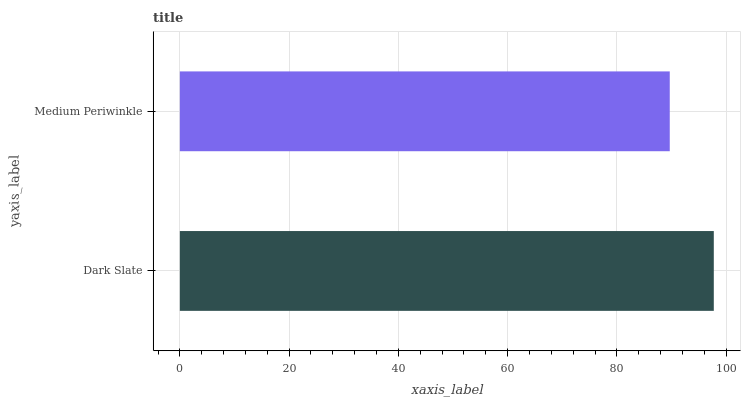Is Medium Periwinkle the minimum?
Answer yes or no. Yes. Is Dark Slate the maximum?
Answer yes or no. Yes. Is Medium Periwinkle the maximum?
Answer yes or no. No. Is Dark Slate greater than Medium Periwinkle?
Answer yes or no. Yes. Is Medium Periwinkle less than Dark Slate?
Answer yes or no. Yes. Is Medium Periwinkle greater than Dark Slate?
Answer yes or no. No. Is Dark Slate less than Medium Periwinkle?
Answer yes or no. No. Is Dark Slate the high median?
Answer yes or no. Yes. Is Medium Periwinkle the low median?
Answer yes or no. Yes. Is Medium Periwinkle the high median?
Answer yes or no. No. Is Dark Slate the low median?
Answer yes or no. No. 